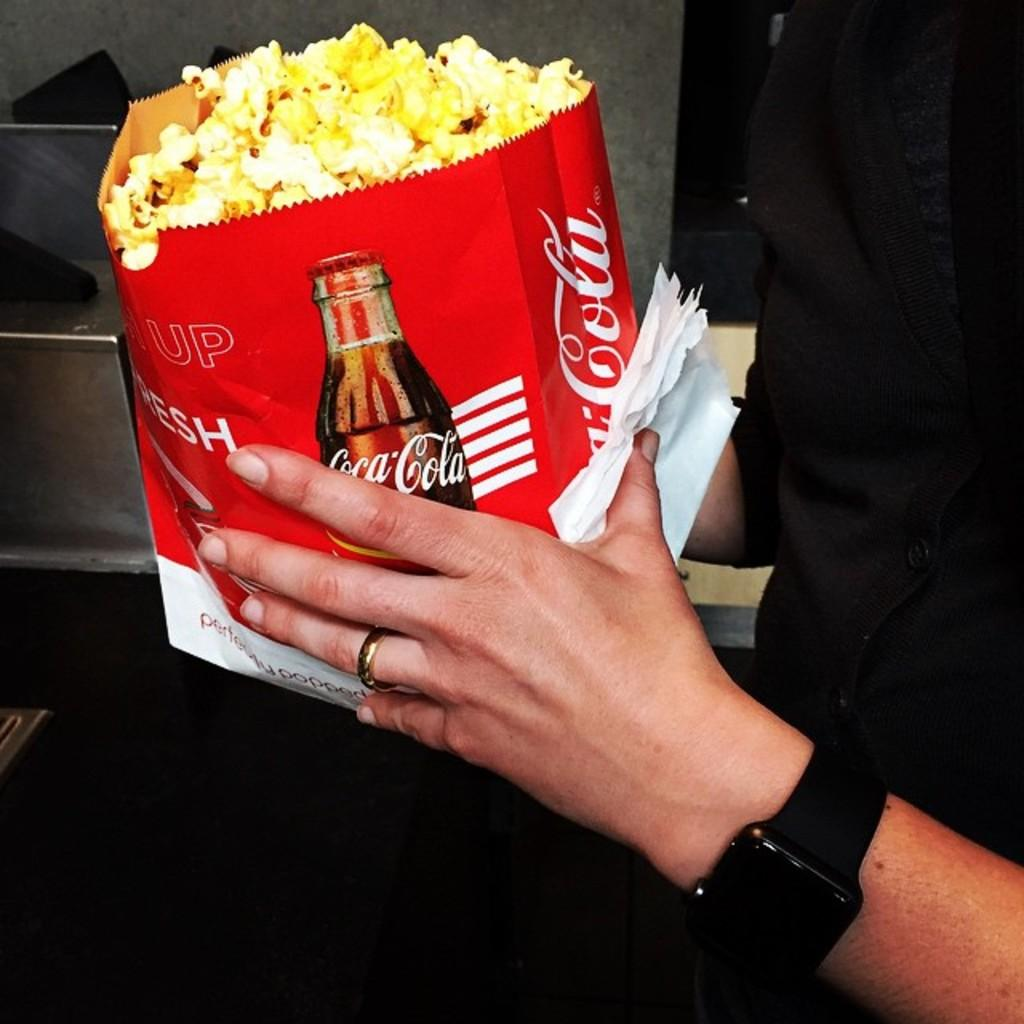<image>
Summarize the visual content of the image. A person is holding a bag of popcorn with a Coca-Cola Logo on it. 